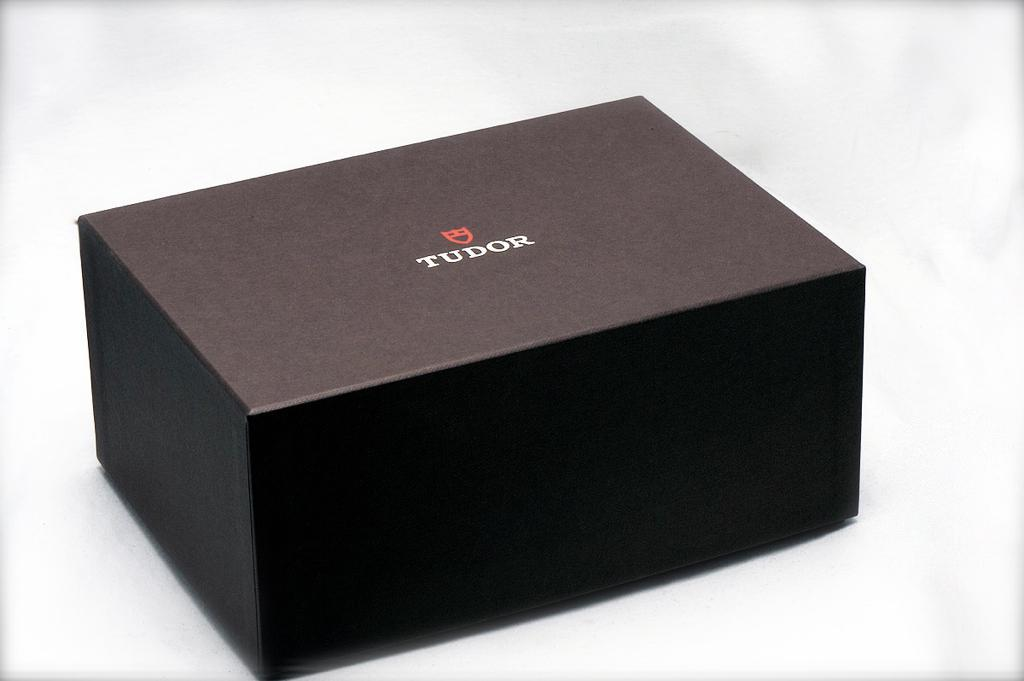<image>
Create a compact narrative representing the image presented. A brown box containing a product from Tudor. 